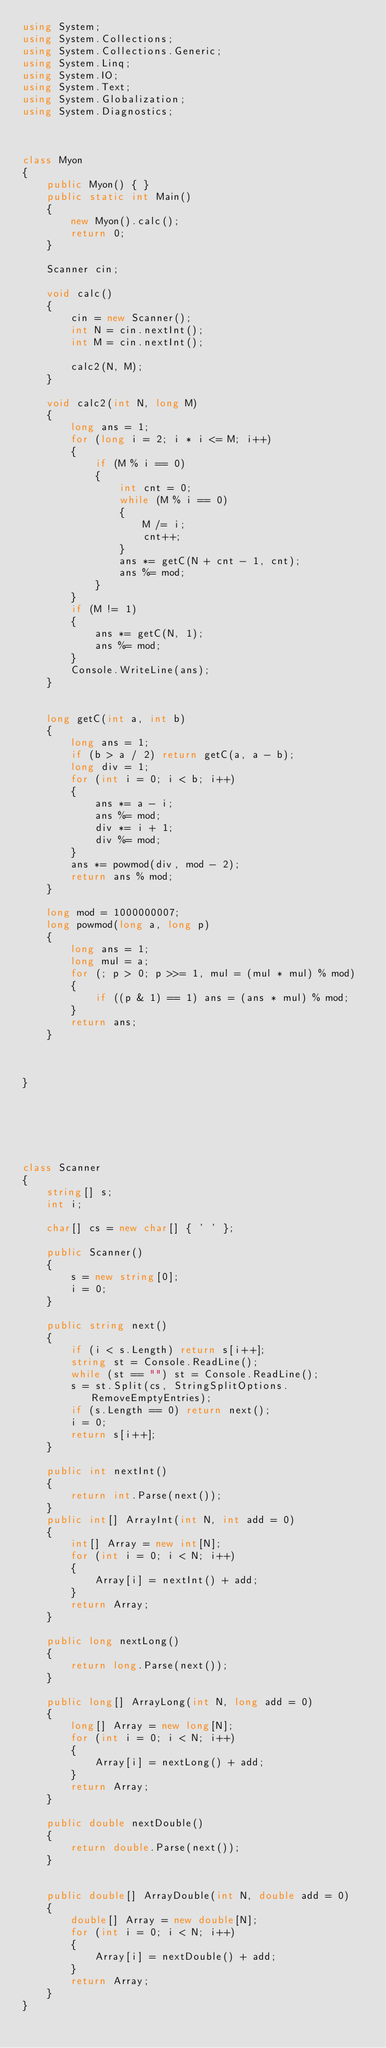<code> <loc_0><loc_0><loc_500><loc_500><_C#_>using System;
using System.Collections;
using System.Collections.Generic;
using System.Linq;
using System.IO;
using System.Text;
using System.Globalization;
using System.Diagnostics;



class Myon
{
    public Myon() { }
    public static int Main()
    {
        new Myon().calc();
        return 0;
    }

    Scanner cin;

    void calc()
    {
        cin = new Scanner();
        int N = cin.nextInt();
        int M = cin.nextInt();

        calc2(N, M);
    }

    void calc2(int N, long M)
    {
        long ans = 1;
        for (long i = 2; i * i <= M; i++)
        {
            if (M % i == 0)
            {
                int cnt = 0;
                while (M % i == 0)
                {
                    M /= i;
                    cnt++;
                }
                ans *= getC(N + cnt - 1, cnt);
                ans %= mod;
            }
        }
        if (M != 1)
        {
            ans *= getC(N, 1);
            ans %= mod;
        }
        Console.WriteLine(ans);
    }


    long getC(int a, int b)
    {
        long ans = 1;
        if (b > a / 2) return getC(a, a - b);
        long div = 1;
        for (int i = 0; i < b; i++)
        {
            ans *= a - i;
            ans %= mod;
            div *= i + 1;
            div %= mod;
        }
        ans *= powmod(div, mod - 2);
        return ans % mod;
    }

    long mod = 1000000007;
    long powmod(long a, long p)
    {
        long ans = 1;
        long mul = a;
        for (; p > 0; p >>= 1, mul = (mul * mul) % mod)
        {
            if ((p & 1) == 1) ans = (ans * mul) % mod;
        }
        return ans;
    }



}






class Scanner
{
    string[] s;
    int i;

    char[] cs = new char[] { ' ' };

    public Scanner()
    {
        s = new string[0];
        i = 0;
    }

    public string next()
    {
        if (i < s.Length) return s[i++];
        string st = Console.ReadLine();
        while (st == "") st = Console.ReadLine();
        s = st.Split(cs, StringSplitOptions.RemoveEmptyEntries);
        if (s.Length == 0) return next();
        i = 0;
        return s[i++];
    }

    public int nextInt()
    {
        return int.Parse(next());
    }
    public int[] ArrayInt(int N, int add = 0)
    {
        int[] Array = new int[N];
        for (int i = 0; i < N; i++)
        {
            Array[i] = nextInt() + add;
        }
        return Array;
    }

    public long nextLong()
    {
        return long.Parse(next());
    }

    public long[] ArrayLong(int N, long add = 0)
    {
        long[] Array = new long[N];
        for (int i = 0; i < N; i++)
        {
            Array[i] = nextLong() + add;
        }
        return Array;
    }

    public double nextDouble()
    {
        return double.Parse(next());
    }


    public double[] ArrayDouble(int N, double add = 0)
    {
        double[] Array = new double[N];
        for (int i = 0; i < N; i++)
        {
            Array[i] = nextDouble() + add;
        }
        return Array;
    }
}
</code> 